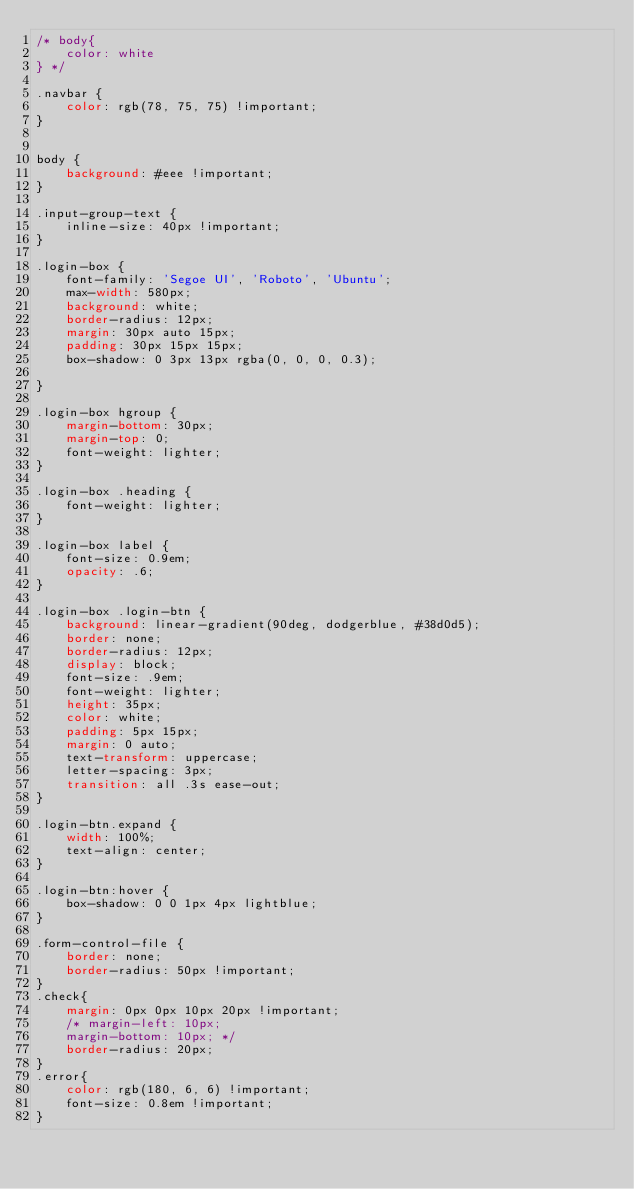<code> <loc_0><loc_0><loc_500><loc_500><_CSS_>/* body{
    color: white
} */

.navbar {
    color: rgb(78, 75, 75) !important;
}


body {
    background: #eee !important;
}

.input-group-text {
    inline-size: 40px !important;
}

.login-box {
    font-family: 'Segoe UI', 'Roboto', 'Ubuntu';
    max-width: 580px;
    background: white;
    border-radius: 12px;
    margin: 30px auto 15px;
    padding: 30px 15px 15px;
    box-shadow: 0 3px 13px rgba(0, 0, 0, 0.3);
    
}

.login-box hgroup {
    margin-bottom: 30px;
    margin-top: 0;
    font-weight: lighter;
}

.login-box .heading {
    font-weight: lighter;
}

.login-box label {
    font-size: 0.9em;
    opacity: .6;
}

.login-box .login-btn {
    background: linear-gradient(90deg, dodgerblue, #38d0d5);
    border: none;
    border-radius: 12px;
    display: block;
    font-size: .9em;
    font-weight: lighter;
    height: 35px;
    color: white;
    padding: 5px 15px;
    margin: 0 auto;
    text-transform: uppercase;
    letter-spacing: 3px;
    transition: all .3s ease-out;
}

.login-btn.expand {
    width: 100%;
    text-align: center;
}

.login-btn:hover {
    box-shadow: 0 0 1px 4px lightblue;
}

.form-control-file {
    border: none;
    border-radius: 50px !important;
}
.check{
    margin: 0px 0px 10px 20px !important;
    /* margin-left: 10px;
    margin-bottom: 10px; */
    border-radius: 20px;
}
.error{
    color: rgb(180, 6, 6) !important;
    font-size: 0.8em !important;
}</code> 